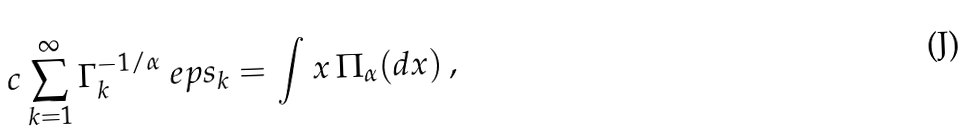Convert formula to latex. <formula><loc_0><loc_0><loc_500><loc_500>c \sum _ { k = 1 } ^ { \infty } \Gamma _ { k } ^ { - 1 / \alpha } \ e p s _ { k } = \int x \, \Pi _ { \alpha } ( d x ) \, ,</formula> 